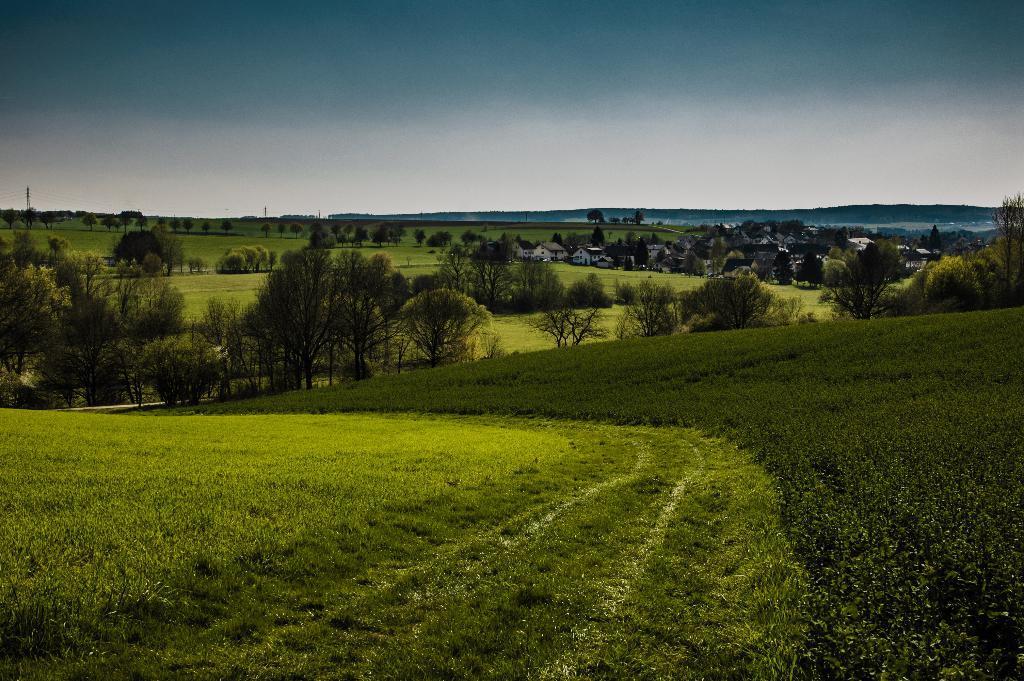In one or two sentences, can you explain what this image depicts? In this image we can see there are houses, plants, trees and the sky. 